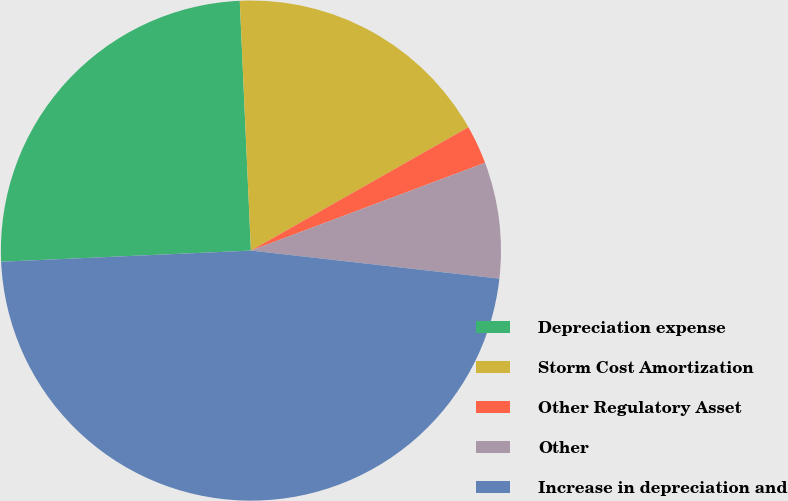Convert chart to OTSL. <chart><loc_0><loc_0><loc_500><loc_500><pie_chart><fcel>Depreciation expense<fcel>Storm Cost Amortization<fcel>Other Regulatory Asset<fcel>Other<fcel>Increase in depreciation and<nl><fcel>25.0%<fcel>17.5%<fcel>2.5%<fcel>7.5%<fcel>47.5%<nl></chart> 